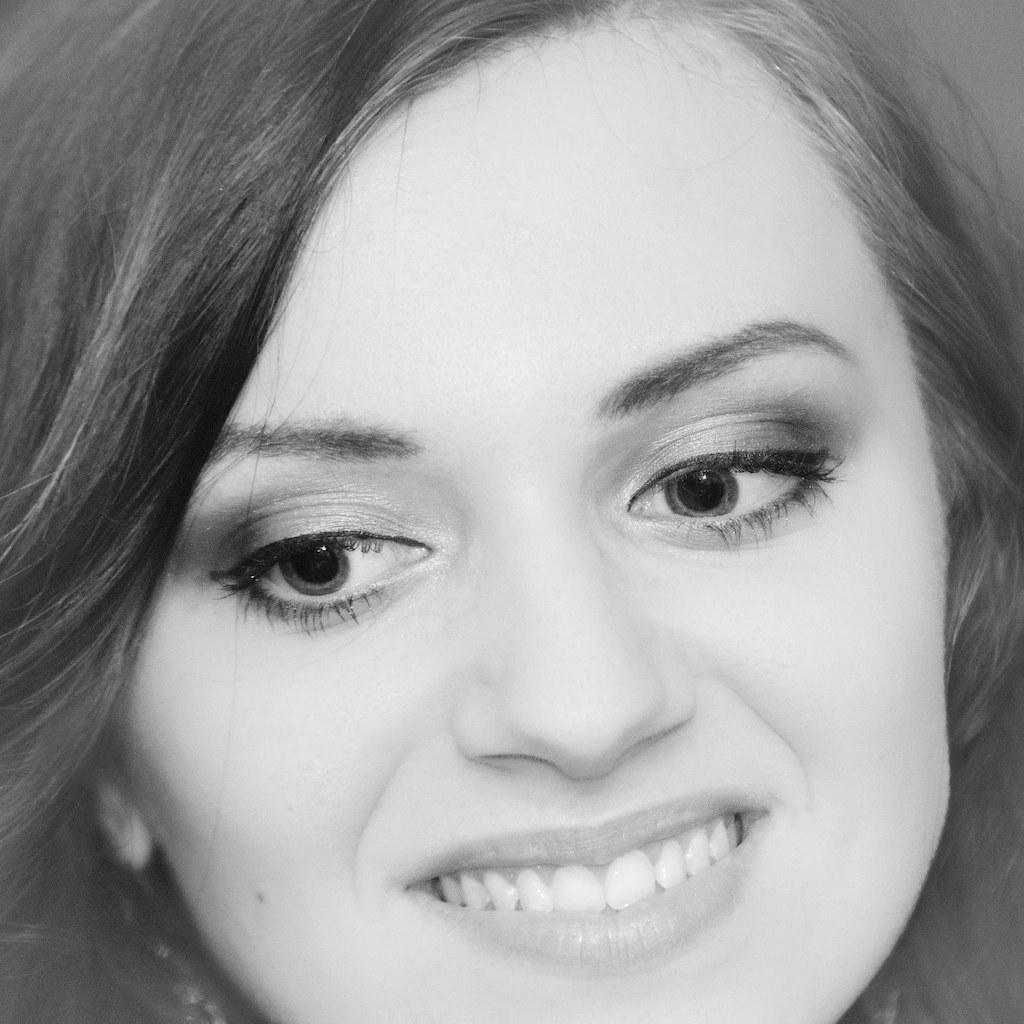What is the main focus of the zoomed-in picture? The main focus of the zoomed-in picture is a person's face. What features can be seen on the person's face? The person's face has eyes, a nose, eyebrows, and a mouth. How is the person's face expressing emotion? The person is smiling. What type of agreement is being signed in the image? There is no agreement or signing activity present in the image; it is a zoomed-in picture of a person's face. Can you see a drum in the image? There is no drum visible in the image; it is a zoomed-in picture of a person's face. 